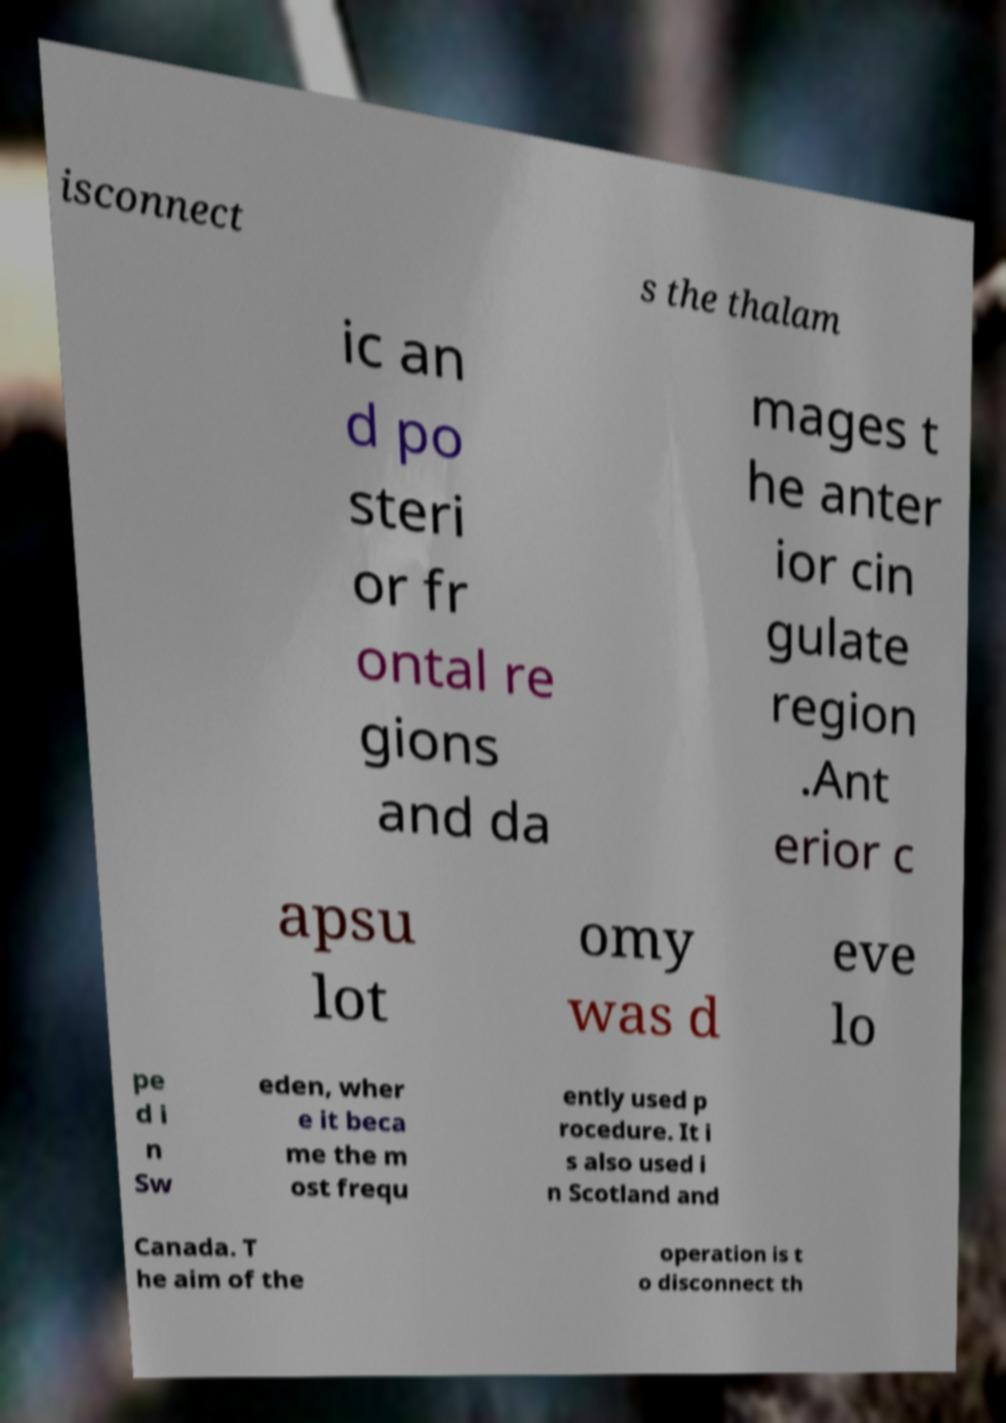For documentation purposes, I need the text within this image transcribed. Could you provide that? isconnect s the thalam ic an d po steri or fr ontal re gions and da mages t he anter ior cin gulate region .Ant erior c apsu lot omy was d eve lo pe d i n Sw eden, wher e it beca me the m ost frequ ently used p rocedure. It i s also used i n Scotland and Canada. T he aim of the operation is t o disconnect th 